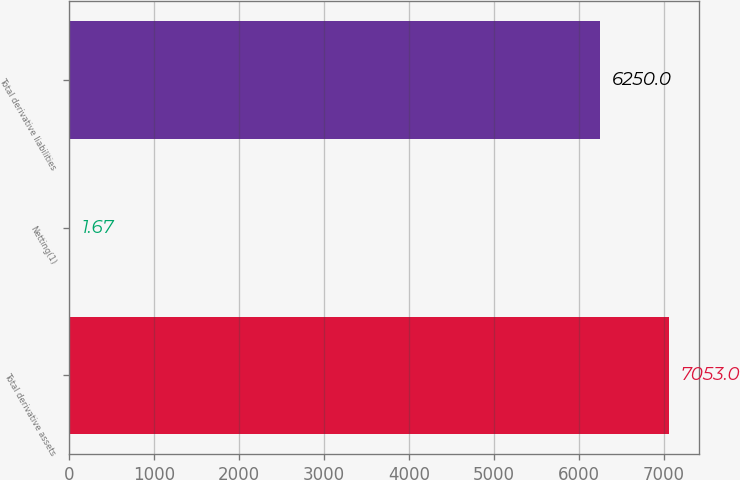<chart> <loc_0><loc_0><loc_500><loc_500><bar_chart><fcel>Total derivative assets<fcel>Netting(1)<fcel>Total derivative liabilities<nl><fcel>7053<fcel>1.67<fcel>6250<nl></chart> 